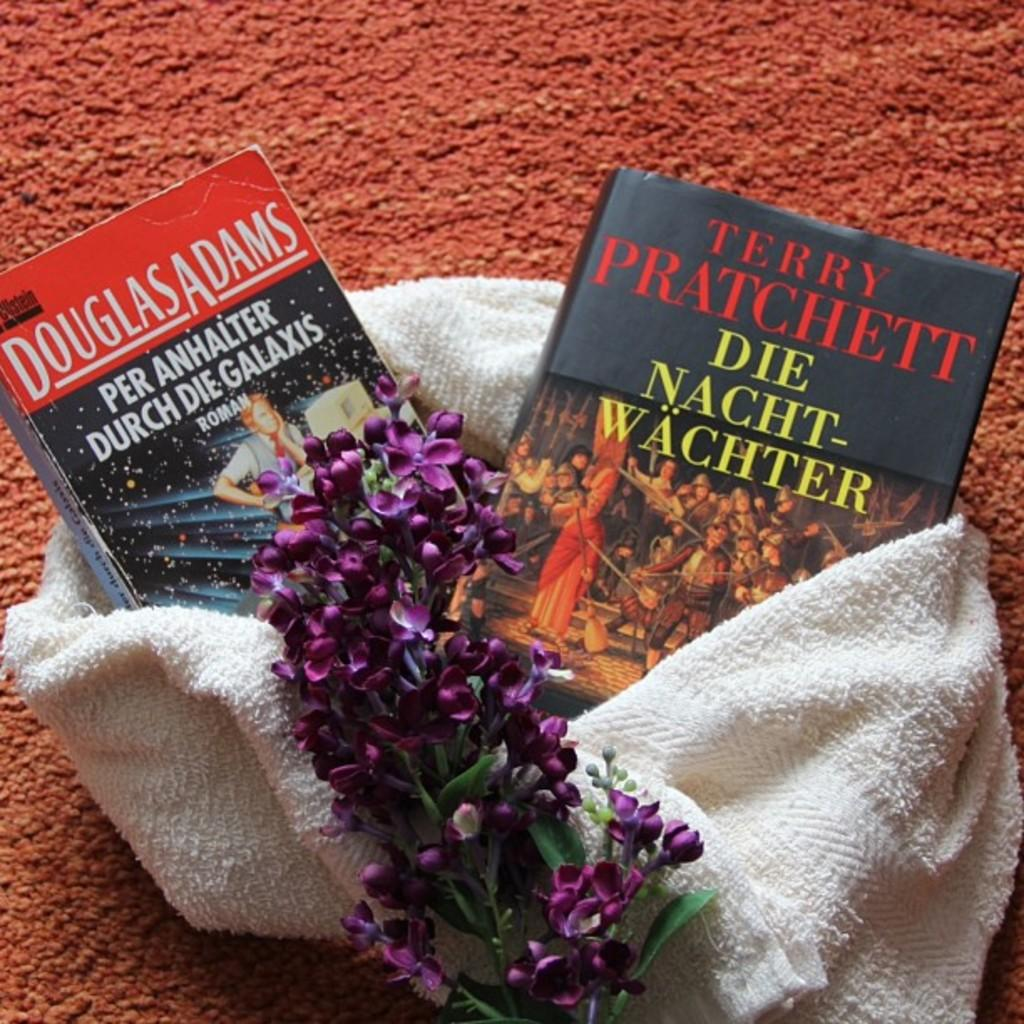What type of living organisms can be seen in the image? There are flowers in the image. What type of inanimate objects can be seen in the image? There are books in the image. On what surface are the flowers and books placed? The flowers and books are on a cloth. What type of pleasure can be seen in the image? There is no indication of pleasure in the image; it features flowers and books on a cloth. What type of thing is elbowing the books in the image? There is no elbow or any other object or person interacting with the books in the image. 